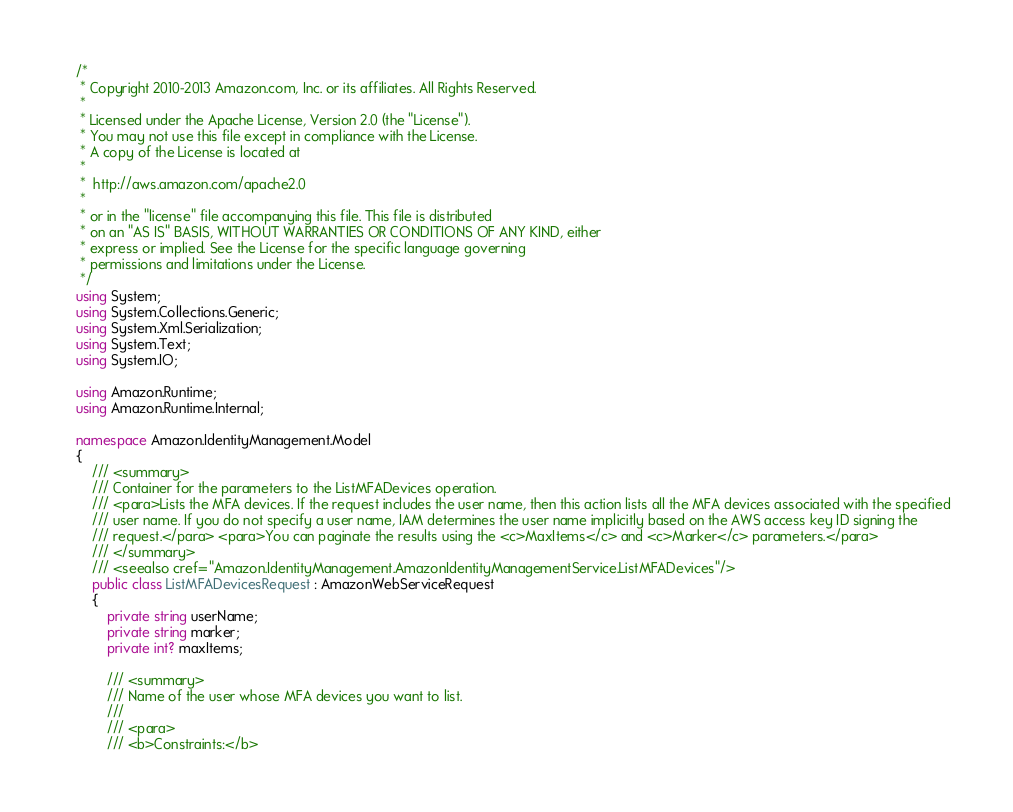Convert code to text. <code><loc_0><loc_0><loc_500><loc_500><_C#_>/*
 * Copyright 2010-2013 Amazon.com, Inc. or its affiliates. All Rights Reserved.
 * 
 * Licensed under the Apache License, Version 2.0 (the "License").
 * You may not use this file except in compliance with the License.
 * A copy of the License is located at
 * 
 *  http://aws.amazon.com/apache2.0
 * 
 * or in the "license" file accompanying this file. This file is distributed
 * on an "AS IS" BASIS, WITHOUT WARRANTIES OR CONDITIONS OF ANY KIND, either
 * express or implied. See the License for the specific language governing
 * permissions and limitations under the License.
 */
using System;
using System.Collections.Generic;
using System.Xml.Serialization;
using System.Text;
using System.IO;

using Amazon.Runtime;
using Amazon.Runtime.Internal;

namespace Amazon.IdentityManagement.Model
{
    /// <summary>
    /// Container for the parameters to the ListMFADevices operation.
    /// <para>Lists the MFA devices. If the request includes the user name, then this action lists all the MFA devices associated with the specified
    /// user name. If you do not specify a user name, IAM determines the user name implicitly based on the AWS access key ID signing the
    /// request.</para> <para>You can paginate the results using the <c>MaxItems</c> and <c>Marker</c> parameters.</para>
    /// </summary>
    /// <seealso cref="Amazon.IdentityManagement.AmazonIdentityManagementService.ListMFADevices"/>
    public class ListMFADevicesRequest : AmazonWebServiceRequest
    {
        private string userName;
        private string marker;
        private int? maxItems;

        /// <summary>
        /// Name of the user whose MFA devices you want to list.
        ///  
        /// <para>
        /// <b>Constraints:</b></code> 